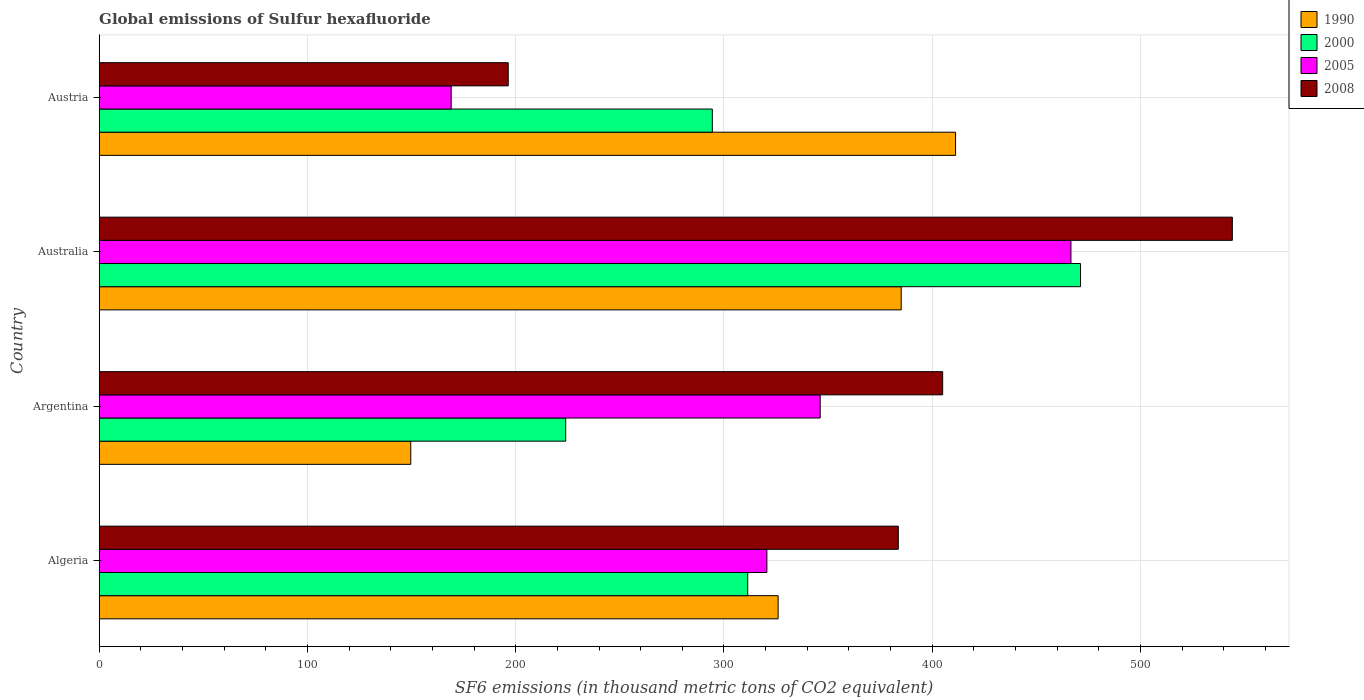How many groups of bars are there?
Offer a terse response. 4. Are the number of bars per tick equal to the number of legend labels?
Your response must be concise. Yes. How many bars are there on the 2nd tick from the bottom?
Ensure brevity in your answer.  4. What is the label of the 2nd group of bars from the top?
Offer a terse response. Australia. In how many cases, is the number of bars for a given country not equal to the number of legend labels?
Your answer should be compact. 0. What is the global emissions of Sulfur hexafluoride in 2008 in Argentina?
Your answer should be very brief. 405. Across all countries, what is the maximum global emissions of Sulfur hexafluoride in 2008?
Make the answer very short. 544.1. Across all countries, what is the minimum global emissions of Sulfur hexafluoride in 2008?
Offer a terse response. 196.4. In which country was the global emissions of Sulfur hexafluoride in 2005 maximum?
Give a very brief answer. Australia. In which country was the global emissions of Sulfur hexafluoride in 1990 minimum?
Offer a terse response. Argentina. What is the total global emissions of Sulfur hexafluoride in 2008 in the graph?
Your answer should be very brief. 1529.2. What is the difference between the global emissions of Sulfur hexafluoride in 2008 in Algeria and that in Argentina?
Offer a terse response. -21.3. What is the difference between the global emissions of Sulfur hexafluoride in 1990 in Argentina and the global emissions of Sulfur hexafluoride in 2005 in Australia?
Make the answer very short. -317. What is the average global emissions of Sulfur hexafluoride in 2000 per country?
Provide a short and direct response. 325.25. What is the difference between the global emissions of Sulfur hexafluoride in 2005 and global emissions of Sulfur hexafluoride in 2000 in Algeria?
Ensure brevity in your answer.  9.2. In how many countries, is the global emissions of Sulfur hexafluoride in 2000 greater than 120 thousand metric tons?
Your answer should be compact. 4. What is the ratio of the global emissions of Sulfur hexafluoride in 2005 in Algeria to that in Austria?
Give a very brief answer. 1.9. Is the difference between the global emissions of Sulfur hexafluoride in 2005 in Algeria and Argentina greater than the difference between the global emissions of Sulfur hexafluoride in 2000 in Algeria and Argentina?
Your response must be concise. No. What is the difference between the highest and the second highest global emissions of Sulfur hexafluoride in 2005?
Make the answer very short. 120.4. What is the difference between the highest and the lowest global emissions of Sulfur hexafluoride in 2005?
Your response must be concise. 297.6. In how many countries, is the global emissions of Sulfur hexafluoride in 2005 greater than the average global emissions of Sulfur hexafluoride in 2005 taken over all countries?
Your answer should be compact. 2. Is it the case that in every country, the sum of the global emissions of Sulfur hexafluoride in 1990 and global emissions of Sulfur hexafluoride in 2005 is greater than the sum of global emissions of Sulfur hexafluoride in 2008 and global emissions of Sulfur hexafluoride in 2000?
Offer a terse response. No. What does the 3rd bar from the top in Australia represents?
Make the answer very short. 2000. What does the 1st bar from the bottom in Austria represents?
Provide a short and direct response. 1990. Are all the bars in the graph horizontal?
Your response must be concise. Yes. How many countries are there in the graph?
Offer a terse response. 4. What is the difference between two consecutive major ticks on the X-axis?
Your response must be concise. 100. Are the values on the major ticks of X-axis written in scientific E-notation?
Keep it short and to the point. No. Does the graph contain any zero values?
Provide a succinct answer. No. How many legend labels are there?
Offer a very short reply. 4. What is the title of the graph?
Offer a very short reply. Global emissions of Sulfur hexafluoride. Does "2004" appear as one of the legend labels in the graph?
Keep it short and to the point. No. What is the label or title of the X-axis?
Give a very brief answer. SF6 emissions (in thousand metric tons of CO2 equivalent). What is the SF6 emissions (in thousand metric tons of CO2 equivalent) in 1990 in Algeria?
Offer a terse response. 326. What is the SF6 emissions (in thousand metric tons of CO2 equivalent) in 2000 in Algeria?
Your answer should be compact. 311.4. What is the SF6 emissions (in thousand metric tons of CO2 equivalent) of 2005 in Algeria?
Keep it short and to the point. 320.6. What is the SF6 emissions (in thousand metric tons of CO2 equivalent) in 2008 in Algeria?
Keep it short and to the point. 383.7. What is the SF6 emissions (in thousand metric tons of CO2 equivalent) of 1990 in Argentina?
Keep it short and to the point. 149.6. What is the SF6 emissions (in thousand metric tons of CO2 equivalent) of 2000 in Argentina?
Make the answer very short. 224. What is the SF6 emissions (in thousand metric tons of CO2 equivalent) in 2005 in Argentina?
Offer a very short reply. 346.2. What is the SF6 emissions (in thousand metric tons of CO2 equivalent) of 2008 in Argentina?
Your response must be concise. 405. What is the SF6 emissions (in thousand metric tons of CO2 equivalent) of 1990 in Australia?
Your answer should be compact. 385.1. What is the SF6 emissions (in thousand metric tons of CO2 equivalent) in 2000 in Australia?
Give a very brief answer. 471.2. What is the SF6 emissions (in thousand metric tons of CO2 equivalent) of 2005 in Australia?
Provide a short and direct response. 466.6. What is the SF6 emissions (in thousand metric tons of CO2 equivalent) in 2008 in Australia?
Offer a very short reply. 544.1. What is the SF6 emissions (in thousand metric tons of CO2 equivalent) of 1990 in Austria?
Offer a very short reply. 411.2. What is the SF6 emissions (in thousand metric tons of CO2 equivalent) of 2000 in Austria?
Provide a short and direct response. 294.4. What is the SF6 emissions (in thousand metric tons of CO2 equivalent) in 2005 in Austria?
Make the answer very short. 169. What is the SF6 emissions (in thousand metric tons of CO2 equivalent) of 2008 in Austria?
Your answer should be very brief. 196.4. Across all countries, what is the maximum SF6 emissions (in thousand metric tons of CO2 equivalent) of 1990?
Your response must be concise. 411.2. Across all countries, what is the maximum SF6 emissions (in thousand metric tons of CO2 equivalent) in 2000?
Provide a succinct answer. 471.2. Across all countries, what is the maximum SF6 emissions (in thousand metric tons of CO2 equivalent) of 2005?
Provide a succinct answer. 466.6. Across all countries, what is the maximum SF6 emissions (in thousand metric tons of CO2 equivalent) of 2008?
Offer a terse response. 544.1. Across all countries, what is the minimum SF6 emissions (in thousand metric tons of CO2 equivalent) of 1990?
Offer a very short reply. 149.6. Across all countries, what is the minimum SF6 emissions (in thousand metric tons of CO2 equivalent) of 2000?
Offer a terse response. 224. Across all countries, what is the minimum SF6 emissions (in thousand metric tons of CO2 equivalent) of 2005?
Make the answer very short. 169. Across all countries, what is the minimum SF6 emissions (in thousand metric tons of CO2 equivalent) of 2008?
Your response must be concise. 196.4. What is the total SF6 emissions (in thousand metric tons of CO2 equivalent) in 1990 in the graph?
Your response must be concise. 1271.9. What is the total SF6 emissions (in thousand metric tons of CO2 equivalent) of 2000 in the graph?
Ensure brevity in your answer.  1301. What is the total SF6 emissions (in thousand metric tons of CO2 equivalent) in 2005 in the graph?
Provide a succinct answer. 1302.4. What is the total SF6 emissions (in thousand metric tons of CO2 equivalent) in 2008 in the graph?
Provide a short and direct response. 1529.2. What is the difference between the SF6 emissions (in thousand metric tons of CO2 equivalent) in 1990 in Algeria and that in Argentina?
Offer a terse response. 176.4. What is the difference between the SF6 emissions (in thousand metric tons of CO2 equivalent) of 2000 in Algeria and that in Argentina?
Provide a short and direct response. 87.4. What is the difference between the SF6 emissions (in thousand metric tons of CO2 equivalent) of 2005 in Algeria and that in Argentina?
Provide a succinct answer. -25.6. What is the difference between the SF6 emissions (in thousand metric tons of CO2 equivalent) in 2008 in Algeria and that in Argentina?
Ensure brevity in your answer.  -21.3. What is the difference between the SF6 emissions (in thousand metric tons of CO2 equivalent) of 1990 in Algeria and that in Australia?
Make the answer very short. -59.1. What is the difference between the SF6 emissions (in thousand metric tons of CO2 equivalent) in 2000 in Algeria and that in Australia?
Keep it short and to the point. -159.8. What is the difference between the SF6 emissions (in thousand metric tons of CO2 equivalent) in 2005 in Algeria and that in Australia?
Offer a very short reply. -146. What is the difference between the SF6 emissions (in thousand metric tons of CO2 equivalent) of 2008 in Algeria and that in Australia?
Your answer should be compact. -160.4. What is the difference between the SF6 emissions (in thousand metric tons of CO2 equivalent) in 1990 in Algeria and that in Austria?
Keep it short and to the point. -85.2. What is the difference between the SF6 emissions (in thousand metric tons of CO2 equivalent) in 2000 in Algeria and that in Austria?
Ensure brevity in your answer.  17. What is the difference between the SF6 emissions (in thousand metric tons of CO2 equivalent) of 2005 in Algeria and that in Austria?
Make the answer very short. 151.6. What is the difference between the SF6 emissions (in thousand metric tons of CO2 equivalent) of 2008 in Algeria and that in Austria?
Offer a very short reply. 187.3. What is the difference between the SF6 emissions (in thousand metric tons of CO2 equivalent) of 1990 in Argentina and that in Australia?
Your answer should be very brief. -235.5. What is the difference between the SF6 emissions (in thousand metric tons of CO2 equivalent) of 2000 in Argentina and that in Australia?
Provide a short and direct response. -247.2. What is the difference between the SF6 emissions (in thousand metric tons of CO2 equivalent) in 2005 in Argentina and that in Australia?
Provide a succinct answer. -120.4. What is the difference between the SF6 emissions (in thousand metric tons of CO2 equivalent) of 2008 in Argentina and that in Australia?
Make the answer very short. -139.1. What is the difference between the SF6 emissions (in thousand metric tons of CO2 equivalent) of 1990 in Argentina and that in Austria?
Give a very brief answer. -261.6. What is the difference between the SF6 emissions (in thousand metric tons of CO2 equivalent) in 2000 in Argentina and that in Austria?
Offer a very short reply. -70.4. What is the difference between the SF6 emissions (in thousand metric tons of CO2 equivalent) of 2005 in Argentina and that in Austria?
Offer a terse response. 177.2. What is the difference between the SF6 emissions (in thousand metric tons of CO2 equivalent) of 2008 in Argentina and that in Austria?
Offer a terse response. 208.6. What is the difference between the SF6 emissions (in thousand metric tons of CO2 equivalent) of 1990 in Australia and that in Austria?
Offer a terse response. -26.1. What is the difference between the SF6 emissions (in thousand metric tons of CO2 equivalent) in 2000 in Australia and that in Austria?
Offer a terse response. 176.8. What is the difference between the SF6 emissions (in thousand metric tons of CO2 equivalent) of 2005 in Australia and that in Austria?
Your answer should be compact. 297.6. What is the difference between the SF6 emissions (in thousand metric tons of CO2 equivalent) of 2008 in Australia and that in Austria?
Your answer should be very brief. 347.7. What is the difference between the SF6 emissions (in thousand metric tons of CO2 equivalent) of 1990 in Algeria and the SF6 emissions (in thousand metric tons of CO2 equivalent) of 2000 in Argentina?
Your answer should be very brief. 102. What is the difference between the SF6 emissions (in thousand metric tons of CO2 equivalent) of 1990 in Algeria and the SF6 emissions (in thousand metric tons of CO2 equivalent) of 2005 in Argentina?
Make the answer very short. -20.2. What is the difference between the SF6 emissions (in thousand metric tons of CO2 equivalent) in 1990 in Algeria and the SF6 emissions (in thousand metric tons of CO2 equivalent) in 2008 in Argentina?
Give a very brief answer. -79. What is the difference between the SF6 emissions (in thousand metric tons of CO2 equivalent) in 2000 in Algeria and the SF6 emissions (in thousand metric tons of CO2 equivalent) in 2005 in Argentina?
Your answer should be very brief. -34.8. What is the difference between the SF6 emissions (in thousand metric tons of CO2 equivalent) of 2000 in Algeria and the SF6 emissions (in thousand metric tons of CO2 equivalent) of 2008 in Argentina?
Provide a short and direct response. -93.6. What is the difference between the SF6 emissions (in thousand metric tons of CO2 equivalent) of 2005 in Algeria and the SF6 emissions (in thousand metric tons of CO2 equivalent) of 2008 in Argentina?
Your response must be concise. -84.4. What is the difference between the SF6 emissions (in thousand metric tons of CO2 equivalent) of 1990 in Algeria and the SF6 emissions (in thousand metric tons of CO2 equivalent) of 2000 in Australia?
Your response must be concise. -145.2. What is the difference between the SF6 emissions (in thousand metric tons of CO2 equivalent) in 1990 in Algeria and the SF6 emissions (in thousand metric tons of CO2 equivalent) in 2005 in Australia?
Provide a short and direct response. -140.6. What is the difference between the SF6 emissions (in thousand metric tons of CO2 equivalent) of 1990 in Algeria and the SF6 emissions (in thousand metric tons of CO2 equivalent) of 2008 in Australia?
Offer a very short reply. -218.1. What is the difference between the SF6 emissions (in thousand metric tons of CO2 equivalent) of 2000 in Algeria and the SF6 emissions (in thousand metric tons of CO2 equivalent) of 2005 in Australia?
Your answer should be very brief. -155.2. What is the difference between the SF6 emissions (in thousand metric tons of CO2 equivalent) in 2000 in Algeria and the SF6 emissions (in thousand metric tons of CO2 equivalent) in 2008 in Australia?
Your answer should be very brief. -232.7. What is the difference between the SF6 emissions (in thousand metric tons of CO2 equivalent) in 2005 in Algeria and the SF6 emissions (in thousand metric tons of CO2 equivalent) in 2008 in Australia?
Your response must be concise. -223.5. What is the difference between the SF6 emissions (in thousand metric tons of CO2 equivalent) in 1990 in Algeria and the SF6 emissions (in thousand metric tons of CO2 equivalent) in 2000 in Austria?
Your answer should be compact. 31.6. What is the difference between the SF6 emissions (in thousand metric tons of CO2 equivalent) of 1990 in Algeria and the SF6 emissions (in thousand metric tons of CO2 equivalent) of 2005 in Austria?
Ensure brevity in your answer.  157. What is the difference between the SF6 emissions (in thousand metric tons of CO2 equivalent) in 1990 in Algeria and the SF6 emissions (in thousand metric tons of CO2 equivalent) in 2008 in Austria?
Your response must be concise. 129.6. What is the difference between the SF6 emissions (in thousand metric tons of CO2 equivalent) of 2000 in Algeria and the SF6 emissions (in thousand metric tons of CO2 equivalent) of 2005 in Austria?
Offer a very short reply. 142.4. What is the difference between the SF6 emissions (in thousand metric tons of CO2 equivalent) of 2000 in Algeria and the SF6 emissions (in thousand metric tons of CO2 equivalent) of 2008 in Austria?
Offer a terse response. 115. What is the difference between the SF6 emissions (in thousand metric tons of CO2 equivalent) of 2005 in Algeria and the SF6 emissions (in thousand metric tons of CO2 equivalent) of 2008 in Austria?
Your answer should be very brief. 124.2. What is the difference between the SF6 emissions (in thousand metric tons of CO2 equivalent) in 1990 in Argentina and the SF6 emissions (in thousand metric tons of CO2 equivalent) in 2000 in Australia?
Offer a very short reply. -321.6. What is the difference between the SF6 emissions (in thousand metric tons of CO2 equivalent) of 1990 in Argentina and the SF6 emissions (in thousand metric tons of CO2 equivalent) of 2005 in Australia?
Provide a short and direct response. -317. What is the difference between the SF6 emissions (in thousand metric tons of CO2 equivalent) of 1990 in Argentina and the SF6 emissions (in thousand metric tons of CO2 equivalent) of 2008 in Australia?
Keep it short and to the point. -394.5. What is the difference between the SF6 emissions (in thousand metric tons of CO2 equivalent) of 2000 in Argentina and the SF6 emissions (in thousand metric tons of CO2 equivalent) of 2005 in Australia?
Keep it short and to the point. -242.6. What is the difference between the SF6 emissions (in thousand metric tons of CO2 equivalent) in 2000 in Argentina and the SF6 emissions (in thousand metric tons of CO2 equivalent) in 2008 in Australia?
Ensure brevity in your answer.  -320.1. What is the difference between the SF6 emissions (in thousand metric tons of CO2 equivalent) in 2005 in Argentina and the SF6 emissions (in thousand metric tons of CO2 equivalent) in 2008 in Australia?
Offer a terse response. -197.9. What is the difference between the SF6 emissions (in thousand metric tons of CO2 equivalent) in 1990 in Argentina and the SF6 emissions (in thousand metric tons of CO2 equivalent) in 2000 in Austria?
Your response must be concise. -144.8. What is the difference between the SF6 emissions (in thousand metric tons of CO2 equivalent) of 1990 in Argentina and the SF6 emissions (in thousand metric tons of CO2 equivalent) of 2005 in Austria?
Provide a succinct answer. -19.4. What is the difference between the SF6 emissions (in thousand metric tons of CO2 equivalent) in 1990 in Argentina and the SF6 emissions (in thousand metric tons of CO2 equivalent) in 2008 in Austria?
Provide a succinct answer. -46.8. What is the difference between the SF6 emissions (in thousand metric tons of CO2 equivalent) of 2000 in Argentina and the SF6 emissions (in thousand metric tons of CO2 equivalent) of 2008 in Austria?
Offer a very short reply. 27.6. What is the difference between the SF6 emissions (in thousand metric tons of CO2 equivalent) in 2005 in Argentina and the SF6 emissions (in thousand metric tons of CO2 equivalent) in 2008 in Austria?
Offer a very short reply. 149.8. What is the difference between the SF6 emissions (in thousand metric tons of CO2 equivalent) in 1990 in Australia and the SF6 emissions (in thousand metric tons of CO2 equivalent) in 2000 in Austria?
Offer a terse response. 90.7. What is the difference between the SF6 emissions (in thousand metric tons of CO2 equivalent) of 1990 in Australia and the SF6 emissions (in thousand metric tons of CO2 equivalent) of 2005 in Austria?
Your answer should be very brief. 216.1. What is the difference between the SF6 emissions (in thousand metric tons of CO2 equivalent) in 1990 in Australia and the SF6 emissions (in thousand metric tons of CO2 equivalent) in 2008 in Austria?
Keep it short and to the point. 188.7. What is the difference between the SF6 emissions (in thousand metric tons of CO2 equivalent) in 2000 in Australia and the SF6 emissions (in thousand metric tons of CO2 equivalent) in 2005 in Austria?
Ensure brevity in your answer.  302.2. What is the difference between the SF6 emissions (in thousand metric tons of CO2 equivalent) in 2000 in Australia and the SF6 emissions (in thousand metric tons of CO2 equivalent) in 2008 in Austria?
Provide a succinct answer. 274.8. What is the difference between the SF6 emissions (in thousand metric tons of CO2 equivalent) of 2005 in Australia and the SF6 emissions (in thousand metric tons of CO2 equivalent) of 2008 in Austria?
Offer a very short reply. 270.2. What is the average SF6 emissions (in thousand metric tons of CO2 equivalent) of 1990 per country?
Keep it short and to the point. 317.98. What is the average SF6 emissions (in thousand metric tons of CO2 equivalent) in 2000 per country?
Your response must be concise. 325.25. What is the average SF6 emissions (in thousand metric tons of CO2 equivalent) in 2005 per country?
Give a very brief answer. 325.6. What is the average SF6 emissions (in thousand metric tons of CO2 equivalent) of 2008 per country?
Ensure brevity in your answer.  382.3. What is the difference between the SF6 emissions (in thousand metric tons of CO2 equivalent) of 1990 and SF6 emissions (in thousand metric tons of CO2 equivalent) of 2000 in Algeria?
Your answer should be very brief. 14.6. What is the difference between the SF6 emissions (in thousand metric tons of CO2 equivalent) of 1990 and SF6 emissions (in thousand metric tons of CO2 equivalent) of 2005 in Algeria?
Keep it short and to the point. 5.4. What is the difference between the SF6 emissions (in thousand metric tons of CO2 equivalent) in 1990 and SF6 emissions (in thousand metric tons of CO2 equivalent) in 2008 in Algeria?
Ensure brevity in your answer.  -57.7. What is the difference between the SF6 emissions (in thousand metric tons of CO2 equivalent) in 2000 and SF6 emissions (in thousand metric tons of CO2 equivalent) in 2005 in Algeria?
Make the answer very short. -9.2. What is the difference between the SF6 emissions (in thousand metric tons of CO2 equivalent) of 2000 and SF6 emissions (in thousand metric tons of CO2 equivalent) of 2008 in Algeria?
Your answer should be compact. -72.3. What is the difference between the SF6 emissions (in thousand metric tons of CO2 equivalent) of 2005 and SF6 emissions (in thousand metric tons of CO2 equivalent) of 2008 in Algeria?
Provide a short and direct response. -63.1. What is the difference between the SF6 emissions (in thousand metric tons of CO2 equivalent) in 1990 and SF6 emissions (in thousand metric tons of CO2 equivalent) in 2000 in Argentina?
Offer a very short reply. -74.4. What is the difference between the SF6 emissions (in thousand metric tons of CO2 equivalent) of 1990 and SF6 emissions (in thousand metric tons of CO2 equivalent) of 2005 in Argentina?
Offer a terse response. -196.6. What is the difference between the SF6 emissions (in thousand metric tons of CO2 equivalent) in 1990 and SF6 emissions (in thousand metric tons of CO2 equivalent) in 2008 in Argentina?
Your answer should be compact. -255.4. What is the difference between the SF6 emissions (in thousand metric tons of CO2 equivalent) in 2000 and SF6 emissions (in thousand metric tons of CO2 equivalent) in 2005 in Argentina?
Your answer should be very brief. -122.2. What is the difference between the SF6 emissions (in thousand metric tons of CO2 equivalent) in 2000 and SF6 emissions (in thousand metric tons of CO2 equivalent) in 2008 in Argentina?
Provide a short and direct response. -181. What is the difference between the SF6 emissions (in thousand metric tons of CO2 equivalent) in 2005 and SF6 emissions (in thousand metric tons of CO2 equivalent) in 2008 in Argentina?
Make the answer very short. -58.8. What is the difference between the SF6 emissions (in thousand metric tons of CO2 equivalent) of 1990 and SF6 emissions (in thousand metric tons of CO2 equivalent) of 2000 in Australia?
Provide a short and direct response. -86.1. What is the difference between the SF6 emissions (in thousand metric tons of CO2 equivalent) of 1990 and SF6 emissions (in thousand metric tons of CO2 equivalent) of 2005 in Australia?
Offer a very short reply. -81.5. What is the difference between the SF6 emissions (in thousand metric tons of CO2 equivalent) in 1990 and SF6 emissions (in thousand metric tons of CO2 equivalent) in 2008 in Australia?
Offer a very short reply. -159. What is the difference between the SF6 emissions (in thousand metric tons of CO2 equivalent) in 2000 and SF6 emissions (in thousand metric tons of CO2 equivalent) in 2008 in Australia?
Give a very brief answer. -72.9. What is the difference between the SF6 emissions (in thousand metric tons of CO2 equivalent) of 2005 and SF6 emissions (in thousand metric tons of CO2 equivalent) of 2008 in Australia?
Your response must be concise. -77.5. What is the difference between the SF6 emissions (in thousand metric tons of CO2 equivalent) in 1990 and SF6 emissions (in thousand metric tons of CO2 equivalent) in 2000 in Austria?
Your response must be concise. 116.8. What is the difference between the SF6 emissions (in thousand metric tons of CO2 equivalent) of 1990 and SF6 emissions (in thousand metric tons of CO2 equivalent) of 2005 in Austria?
Make the answer very short. 242.2. What is the difference between the SF6 emissions (in thousand metric tons of CO2 equivalent) in 1990 and SF6 emissions (in thousand metric tons of CO2 equivalent) in 2008 in Austria?
Your answer should be compact. 214.8. What is the difference between the SF6 emissions (in thousand metric tons of CO2 equivalent) in 2000 and SF6 emissions (in thousand metric tons of CO2 equivalent) in 2005 in Austria?
Give a very brief answer. 125.4. What is the difference between the SF6 emissions (in thousand metric tons of CO2 equivalent) in 2000 and SF6 emissions (in thousand metric tons of CO2 equivalent) in 2008 in Austria?
Give a very brief answer. 98. What is the difference between the SF6 emissions (in thousand metric tons of CO2 equivalent) in 2005 and SF6 emissions (in thousand metric tons of CO2 equivalent) in 2008 in Austria?
Your response must be concise. -27.4. What is the ratio of the SF6 emissions (in thousand metric tons of CO2 equivalent) of 1990 in Algeria to that in Argentina?
Give a very brief answer. 2.18. What is the ratio of the SF6 emissions (in thousand metric tons of CO2 equivalent) in 2000 in Algeria to that in Argentina?
Provide a succinct answer. 1.39. What is the ratio of the SF6 emissions (in thousand metric tons of CO2 equivalent) of 2005 in Algeria to that in Argentina?
Offer a very short reply. 0.93. What is the ratio of the SF6 emissions (in thousand metric tons of CO2 equivalent) of 1990 in Algeria to that in Australia?
Make the answer very short. 0.85. What is the ratio of the SF6 emissions (in thousand metric tons of CO2 equivalent) of 2000 in Algeria to that in Australia?
Keep it short and to the point. 0.66. What is the ratio of the SF6 emissions (in thousand metric tons of CO2 equivalent) in 2005 in Algeria to that in Australia?
Ensure brevity in your answer.  0.69. What is the ratio of the SF6 emissions (in thousand metric tons of CO2 equivalent) in 2008 in Algeria to that in Australia?
Your answer should be very brief. 0.71. What is the ratio of the SF6 emissions (in thousand metric tons of CO2 equivalent) in 1990 in Algeria to that in Austria?
Your response must be concise. 0.79. What is the ratio of the SF6 emissions (in thousand metric tons of CO2 equivalent) in 2000 in Algeria to that in Austria?
Give a very brief answer. 1.06. What is the ratio of the SF6 emissions (in thousand metric tons of CO2 equivalent) of 2005 in Algeria to that in Austria?
Provide a short and direct response. 1.9. What is the ratio of the SF6 emissions (in thousand metric tons of CO2 equivalent) of 2008 in Algeria to that in Austria?
Your answer should be compact. 1.95. What is the ratio of the SF6 emissions (in thousand metric tons of CO2 equivalent) of 1990 in Argentina to that in Australia?
Keep it short and to the point. 0.39. What is the ratio of the SF6 emissions (in thousand metric tons of CO2 equivalent) of 2000 in Argentina to that in Australia?
Ensure brevity in your answer.  0.48. What is the ratio of the SF6 emissions (in thousand metric tons of CO2 equivalent) in 2005 in Argentina to that in Australia?
Offer a very short reply. 0.74. What is the ratio of the SF6 emissions (in thousand metric tons of CO2 equivalent) of 2008 in Argentina to that in Australia?
Offer a very short reply. 0.74. What is the ratio of the SF6 emissions (in thousand metric tons of CO2 equivalent) of 1990 in Argentina to that in Austria?
Keep it short and to the point. 0.36. What is the ratio of the SF6 emissions (in thousand metric tons of CO2 equivalent) in 2000 in Argentina to that in Austria?
Your response must be concise. 0.76. What is the ratio of the SF6 emissions (in thousand metric tons of CO2 equivalent) of 2005 in Argentina to that in Austria?
Your response must be concise. 2.05. What is the ratio of the SF6 emissions (in thousand metric tons of CO2 equivalent) of 2008 in Argentina to that in Austria?
Offer a terse response. 2.06. What is the ratio of the SF6 emissions (in thousand metric tons of CO2 equivalent) of 1990 in Australia to that in Austria?
Offer a terse response. 0.94. What is the ratio of the SF6 emissions (in thousand metric tons of CO2 equivalent) in 2000 in Australia to that in Austria?
Give a very brief answer. 1.6. What is the ratio of the SF6 emissions (in thousand metric tons of CO2 equivalent) of 2005 in Australia to that in Austria?
Offer a very short reply. 2.76. What is the ratio of the SF6 emissions (in thousand metric tons of CO2 equivalent) in 2008 in Australia to that in Austria?
Offer a terse response. 2.77. What is the difference between the highest and the second highest SF6 emissions (in thousand metric tons of CO2 equivalent) of 1990?
Make the answer very short. 26.1. What is the difference between the highest and the second highest SF6 emissions (in thousand metric tons of CO2 equivalent) of 2000?
Give a very brief answer. 159.8. What is the difference between the highest and the second highest SF6 emissions (in thousand metric tons of CO2 equivalent) of 2005?
Your answer should be compact. 120.4. What is the difference between the highest and the second highest SF6 emissions (in thousand metric tons of CO2 equivalent) in 2008?
Keep it short and to the point. 139.1. What is the difference between the highest and the lowest SF6 emissions (in thousand metric tons of CO2 equivalent) of 1990?
Give a very brief answer. 261.6. What is the difference between the highest and the lowest SF6 emissions (in thousand metric tons of CO2 equivalent) of 2000?
Ensure brevity in your answer.  247.2. What is the difference between the highest and the lowest SF6 emissions (in thousand metric tons of CO2 equivalent) in 2005?
Your response must be concise. 297.6. What is the difference between the highest and the lowest SF6 emissions (in thousand metric tons of CO2 equivalent) of 2008?
Ensure brevity in your answer.  347.7. 